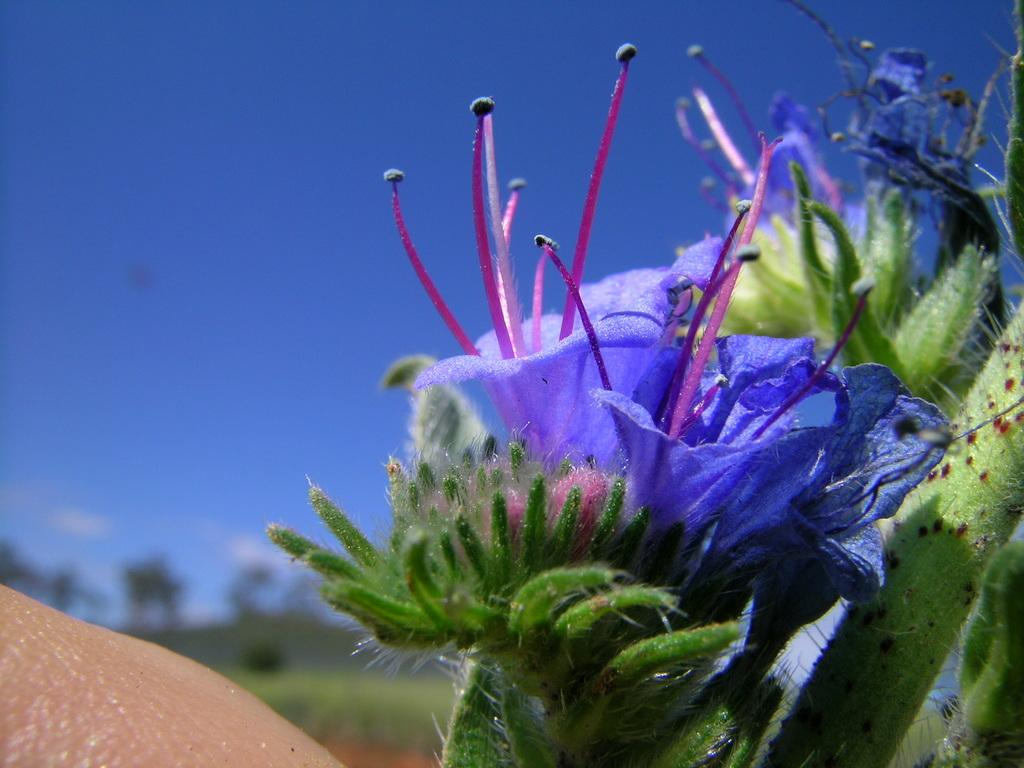What type of flowers can be seen in the image? There are blue color flowers in the image. How would you describe the background of the image? The background of the image is slightly blurred. What can be seen in the distance in the image? Trees are visible in the background of the image. What is the color of the sky in the image? The sky is blue in the background of the image. Where is the toothbrush located in the image? There is no toothbrush present in the image. What is the cause of death in the image? There is no reference to death or any related events in the image. 